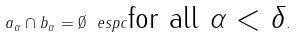Convert formula to latex. <formula><loc_0><loc_0><loc_500><loc_500>a _ { \alpha } \cap b _ { \alpha } = \emptyset \ e s p c \text {for all $\alpha<\delta$} .</formula> 